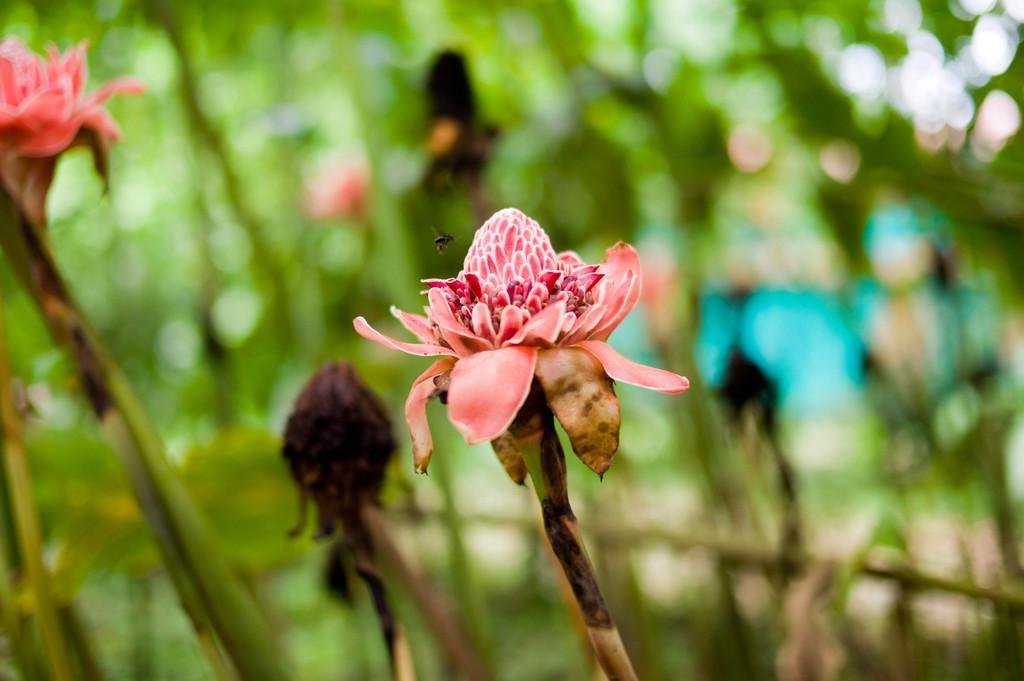Could you give a brief overview of what you see in this image? In the image we can see some flowers and there is a insect. Background of the image is blur. 